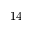<formula> <loc_0><loc_0><loc_500><loc_500>1 4</formula> 